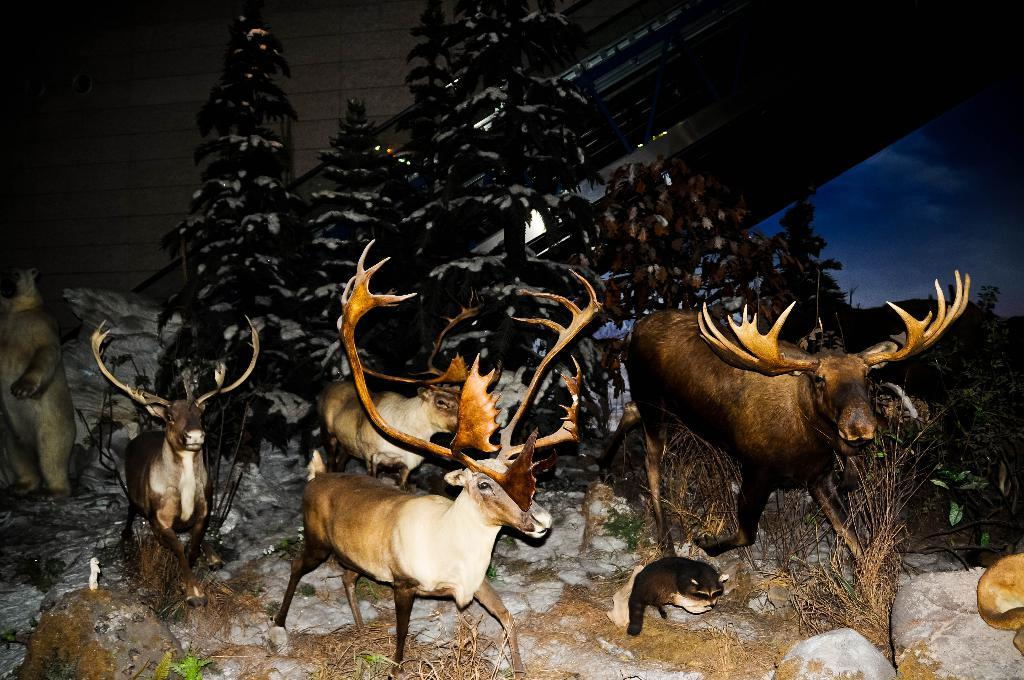What is located in the center of the image? There are animals in the center of the image. What can be seen in the background of the image? There are trees in the background of the image. What is present on the ground in the front of the image? There are stones on the ground in the front of the image. What type of string can be seen connecting the animals in the image? There is no string present in the image; the animals are not connected by any visible string. 